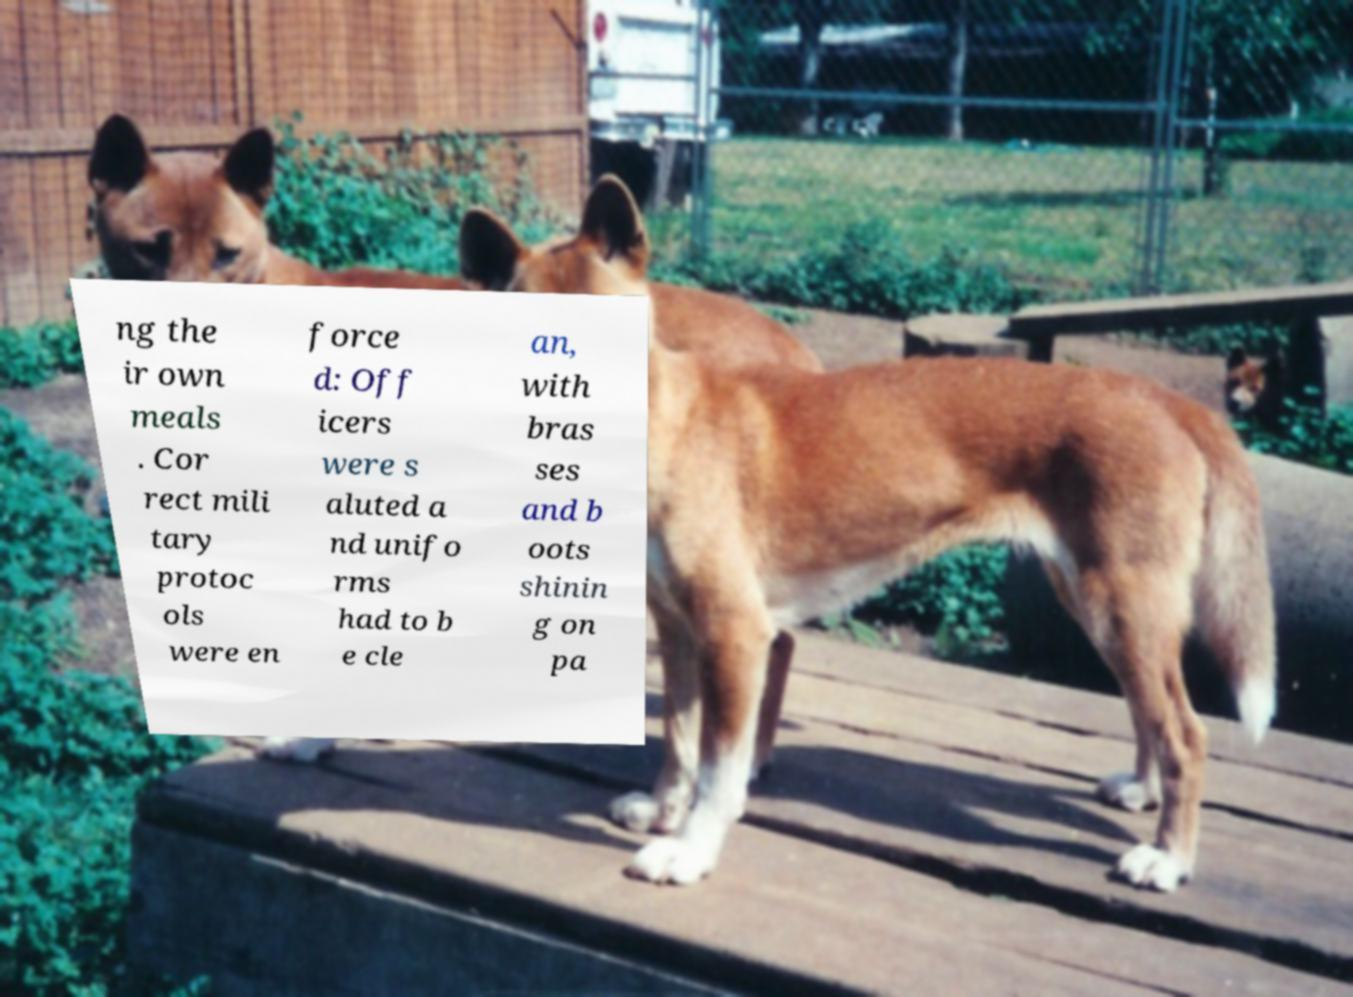Please read and relay the text visible in this image. What does it say? ng the ir own meals . Cor rect mili tary protoc ols were en force d: Off icers were s aluted a nd unifo rms had to b e cle an, with bras ses and b oots shinin g on pa 